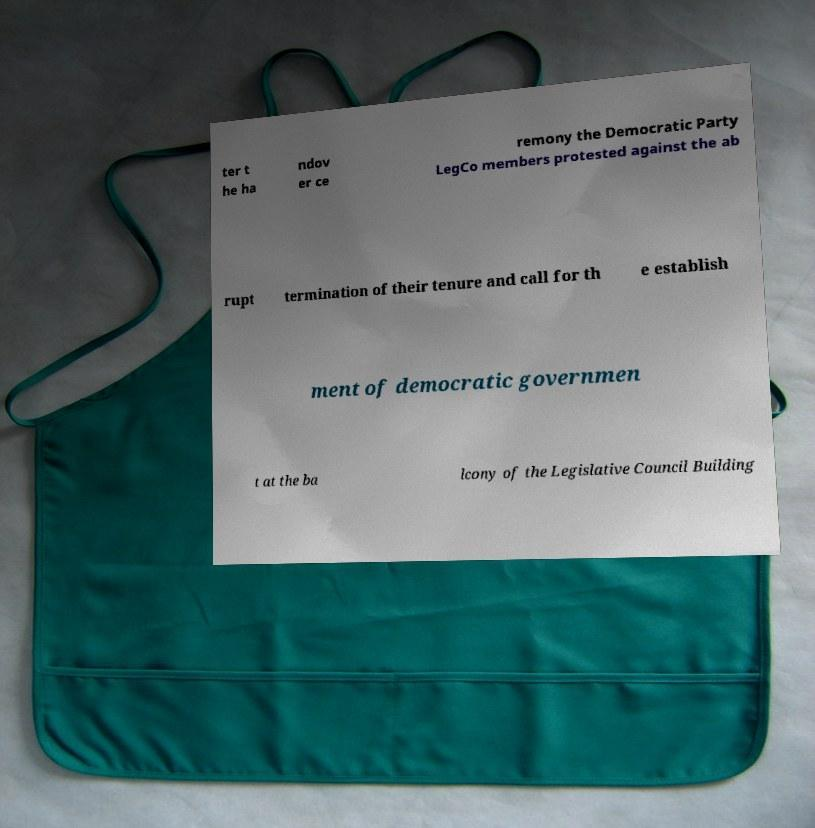Please read and relay the text visible in this image. What does it say? ter t he ha ndov er ce remony the Democratic Party LegCo members protested against the ab rupt termination of their tenure and call for th e establish ment of democratic governmen t at the ba lcony of the Legislative Council Building 